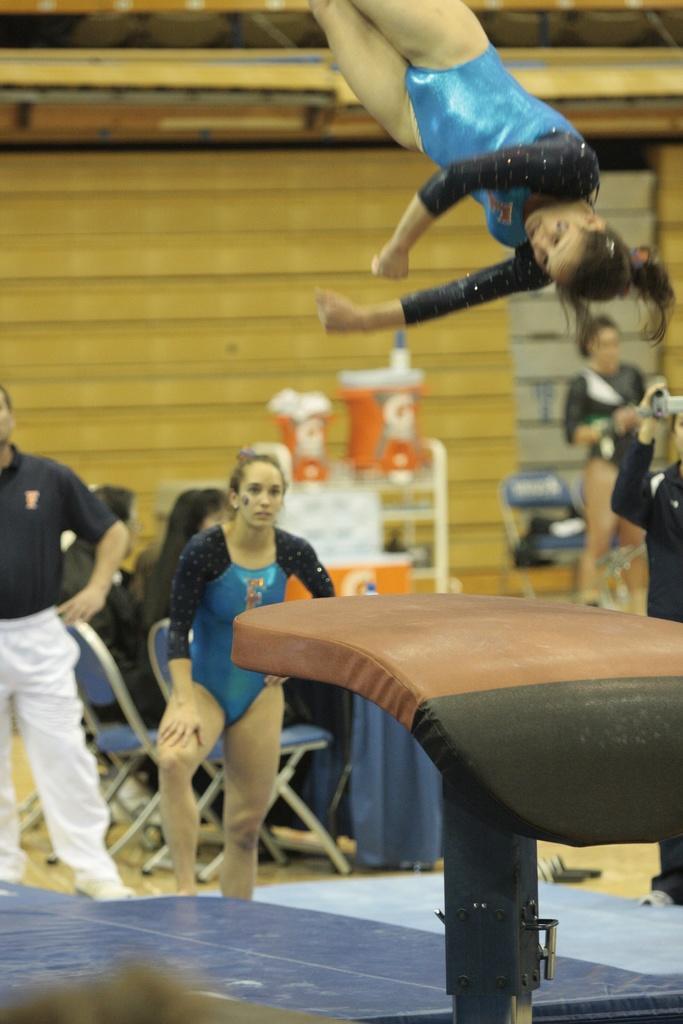Could you give a brief overview of what you see in this image? In this image in the middle, there is a woman, she wears a dress. On the left there is a man, he wears a t shirt, trouser, shoes. On the right there is a woman, she wears a t shirt, trouser and shoes. At the bottom there is a couch. At the top there is a woman, she wears a dress. In the background there are some people, chairs, table, cloth and wall. 